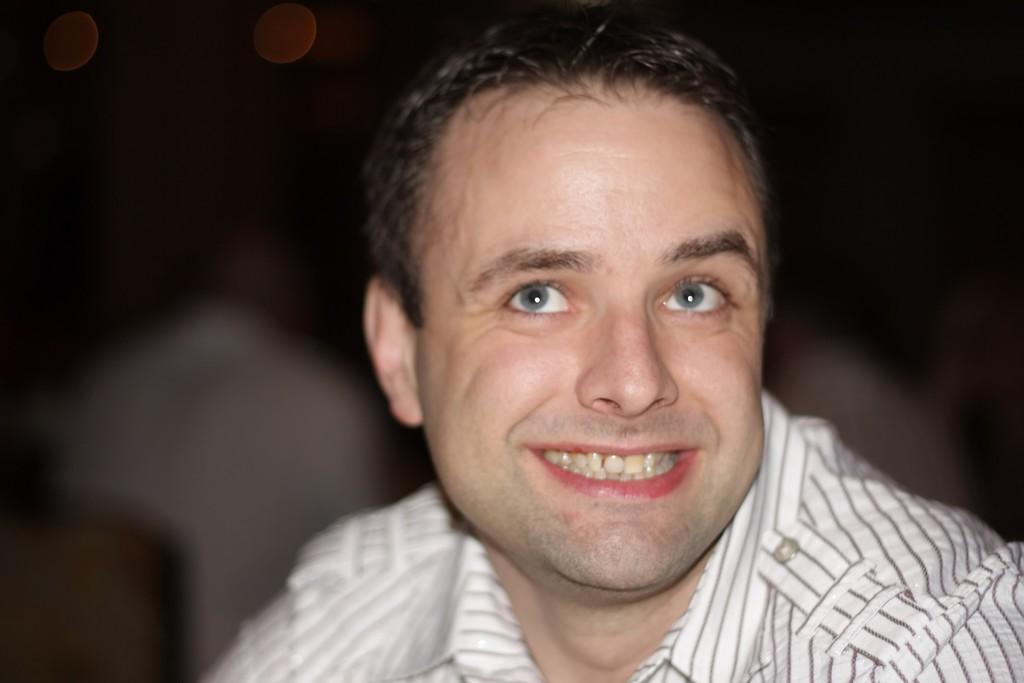Please provide a concise description of this image. In the foreground of this picture, there is a man in white shirt having smile on his face and the background is blurred. 